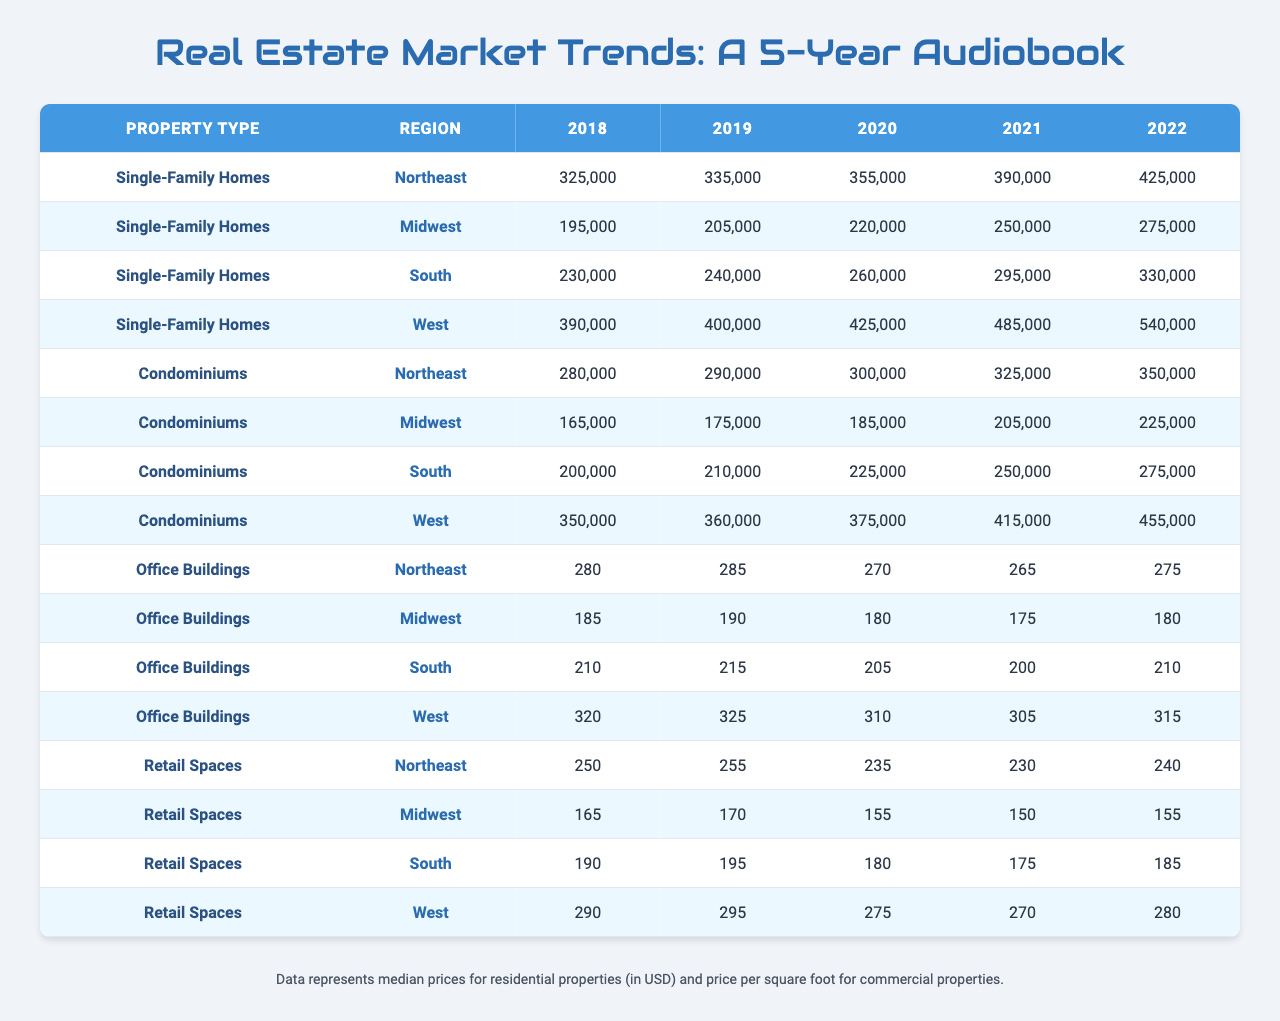What was the median price of Single-Family Homes in the Northeast region in 2020? In the table, under the category "Single-Family Homes" for the "Northeast" region, the median price for the year 2020 is provided as 355,000.
Answer: 355,000 Which property type had the highest median price in the South region in 2022? Looking at the table, for the South region in 2022, "Single-Family Homes" had a median price of 330,000 while "Condominiums" had a price of 275,000. Therefore, "Single-Family Homes" had the highest median price.
Answer: Single-Family Homes What was the difference in median price for Office Buildings in the Midwest from 2018 to 2022? The median price for Office Buildings in the Midwest in 2018 was 185, and in 2022 it was 180. To find the difference: 180 - 185 = -5, indicating a decrease.
Answer: -5 What was the average median price of Condominiums across all regions in 2021? The median prices for Condominiums in 2021 for each region are: Northeast 325,000, Midwest 205,000, South 250,000, West 415,000. To find the average, sum these prices: 325,000 + 205,000 + 250,000 + 415,000 = 1,195,000, then divide by 4, resulting in 1,195,000 / 4 = 298,750.
Answer: 298,750 Did the price for Retail Spaces in the Northeast increase or decrease from 2018 to 2022? In the table, the price for Retail Spaces in the Northeast was 250 in 2018 and 240 in 2022. The decrease can be determined since 240 is less than 250.
Answer: Decrease What is the total median price of Commercial properties in the South for the year 2022? The median prices for Commercial properties in the South in 2022 are: Office Buildings 210 and Retail Spaces 185. To find the total, add these prices: 210 + 185 = 395.
Answer: 395 How much did the median price of Single-Family Homes in the West increase from 2018 to 2022? In the West region, the median price for Single-Family Homes was 390,000 in 2018 and 540,000 in 2022. The increase can be calculated by subtracting: 540,000 - 390,000 = 150,000.
Answer: 150,000 Which region saw the greatest price increase for Condominiums from 2018 to 2022? For Condominiums, the price increases by region are calculated as follows: Northeast (350,000 - 280,000 = 70,000), Midwest (225,000 - 165,000 = 60,000), South (275,000 - 200,000 = 75,000), West (455,000 - 350,000 = 105,000). The largest increase is 105,000 in the West.
Answer: West Which property type generally has a higher median price in the Northeast region throughout the years? By comparing the median prices side by side for each year: Single-Family Homes consistently had prices above those of Condominiums. Specifically, Single-Family Homes had 325,000 (2018) compared to 280,000 (Condominiums). This trend continues each year.
Answer: Single-Family Homes What was the trend in median prices for Office Buildings in the Midwest over the last 5 years? The prices from 2018 to 2022 for Office Buildings in the Midwest were: 185, 190, 180, 175, and 180. The trend initially increased slightly from 2018 to 2019, then decreased until 2021, followed by a slight increase in 2022, indicating fluctuation rather than a consistent trend.
Answer: Fluctuating trend 